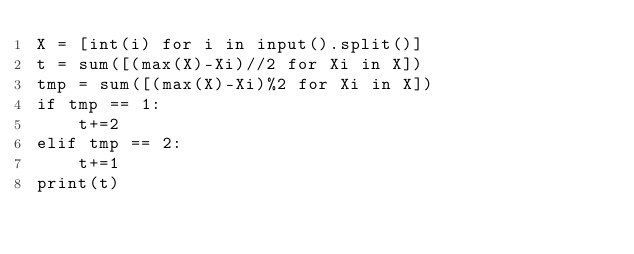Convert code to text. <code><loc_0><loc_0><loc_500><loc_500><_Python_>X = [int(i) for i in input().split()]
t = sum([(max(X)-Xi)//2 for Xi in X])
tmp = sum([(max(X)-Xi)%2 for Xi in X])
if tmp == 1:
    t+=2
elif tmp == 2:
    t+=1
print(t)</code> 